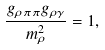Convert formula to latex. <formula><loc_0><loc_0><loc_500><loc_500>\frac { g _ { \rho \pi \pi } g _ { \rho \gamma } } { m _ { \rho } ^ { 2 } } = 1 ,</formula> 